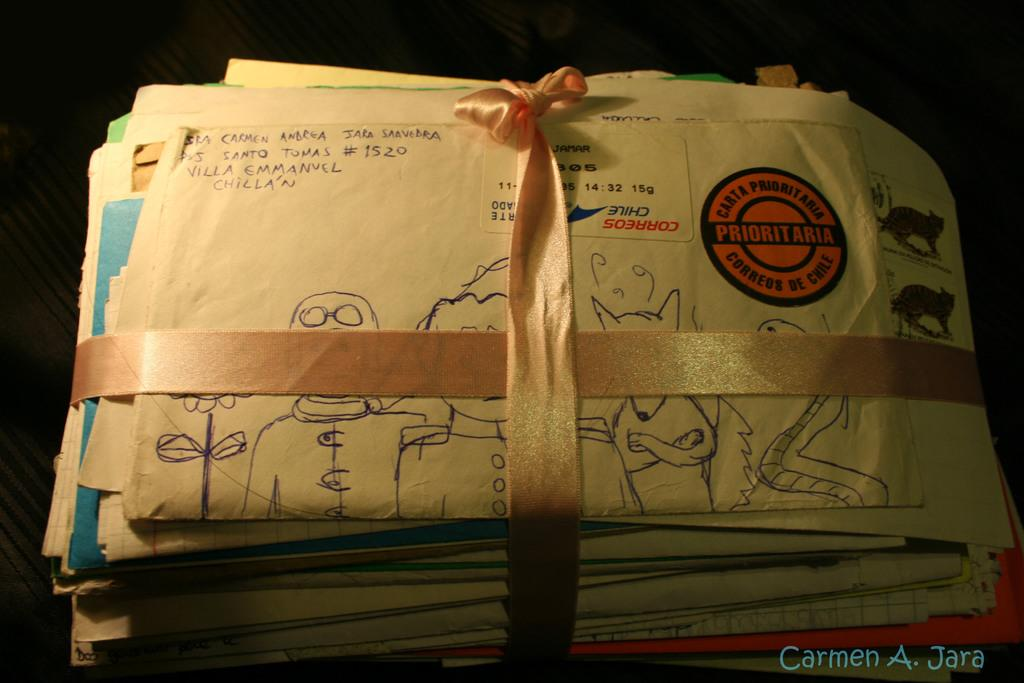<image>
Present a compact description of the photo's key features. Carmen A. Jara photograph of envelopes with Prioritaria badge on front cover. 